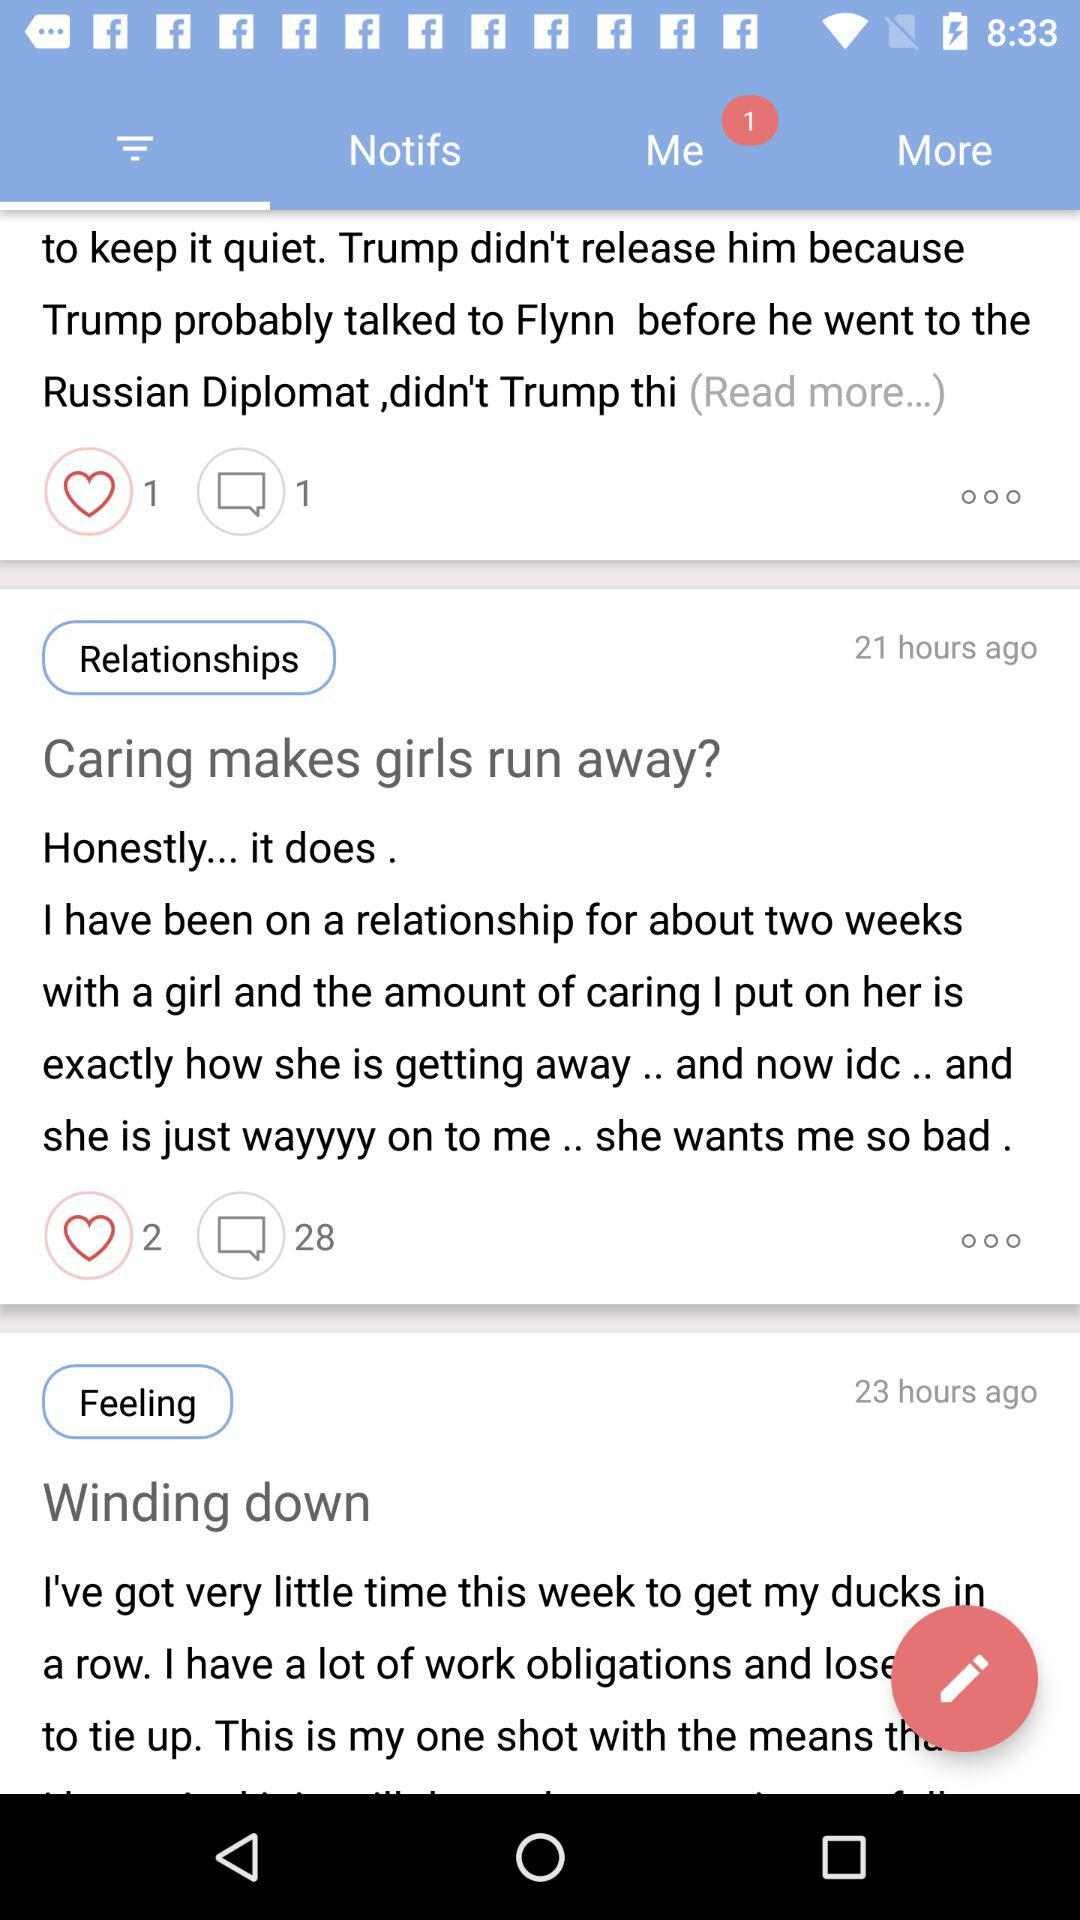How many hours ago was the "Winding down" posted? The "Winding down" was posted 23 hours ago. 